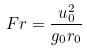<formula> <loc_0><loc_0><loc_500><loc_500>F r = \frac { u _ { 0 } ^ { 2 } } { g _ { 0 } r _ { 0 } }</formula> 